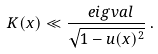<formula> <loc_0><loc_0><loc_500><loc_500>K ( x ) \ll \frac { \ e i g v a l } { \sqrt { 1 - u ( x ) ^ { 2 } } } \, .</formula> 